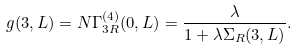Convert formula to latex. <formula><loc_0><loc_0><loc_500><loc_500>g ( 3 , L ) = N \Gamma _ { 3 R } ^ { ( 4 ) } ( 0 , L ) = \frac { \lambda } { 1 + \lambda \Sigma _ { R } ( 3 , L ) } .</formula> 